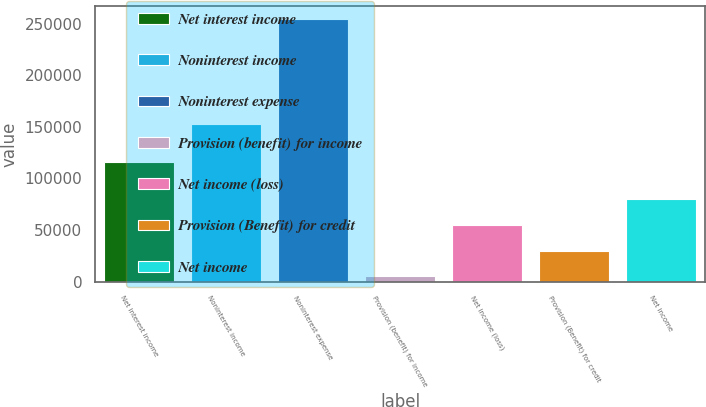Convert chart to OTSL. <chart><loc_0><loc_0><loc_500><loc_500><bar_chart><fcel>Net interest income<fcel>Noninterest income<fcel>Noninterest expense<fcel>Provision (benefit) for income<fcel>Net income (loss)<fcel>Provision (Benefit) for credit<fcel>Net income<nl><fcel>115608<fcel>153160<fcel>254380<fcel>5013<fcel>54886.4<fcel>29949.7<fcel>79823.1<nl></chart> 